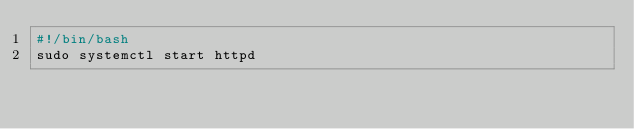Convert code to text. <code><loc_0><loc_0><loc_500><loc_500><_Bash_>#!/bin/bash
sudo systemctl start httpd</code> 